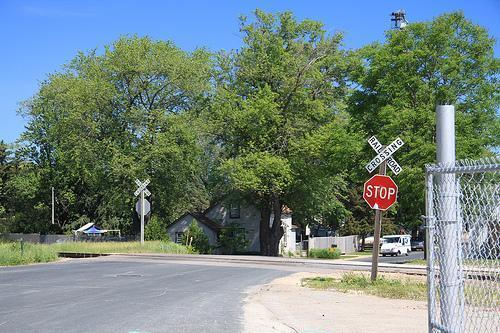How many stop signs are there?
Give a very brief answer. 2. 